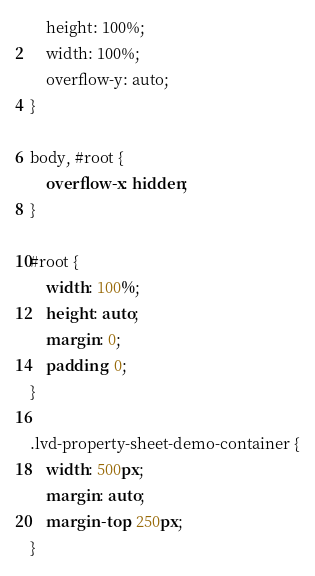Convert code to text. <code><loc_0><loc_0><loc_500><loc_500><_CSS_>	height: 100%;
	width: 100%;
	overflow-y: auto;
}

body, #root {
	overflow-x: hidden;
}

#root {
	width: 100%;
	height: auto;
	margin: 0;
	padding: 0;
}

.lvd-property-sheet-demo-container {
	width: 500px;
	margin: auto;
	margin-top: 250px;
}</code> 